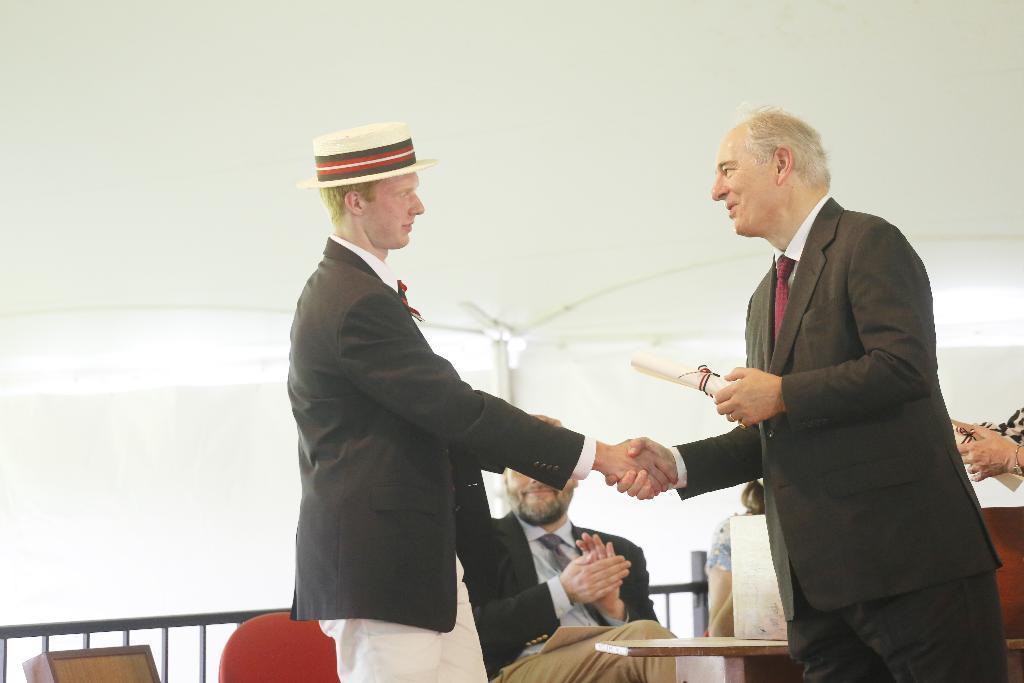Could you give a brief overview of what you see in this image? In the picture we can see two men are standing and shaking hands and they are in blazers and behind them we can see another man sitting on the chair and he is also in the blazer, tie and shirt and behind him we can see a railing and wall. 